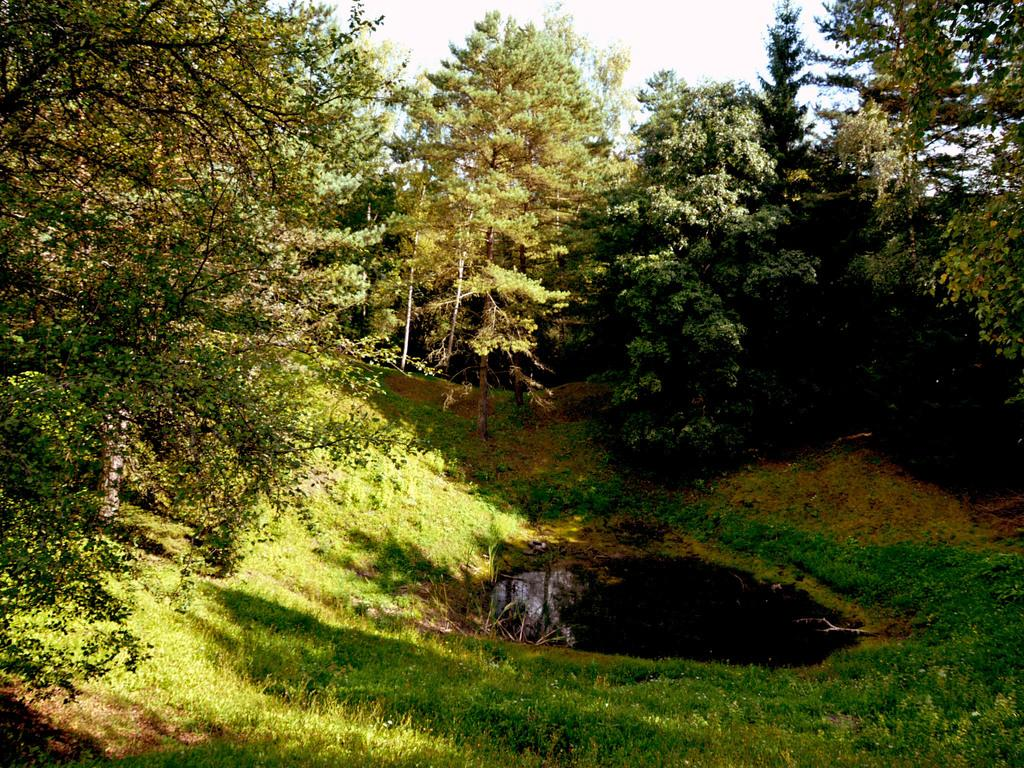What type of vegetation can be seen in the image? There are trees in the image. What else can be seen on the ground in the image? There is grass in the image. What is visible in the image besides the vegetation? There is water visible in the image. What is visible in the background of the image? The sky is visible in the image. What is the purpose of the chess pieces in the image? There are no chess pieces present in the image. How does the motion of the water in the image affect the surrounding environment? There is no motion of the water in the image; it is still and not moving. 